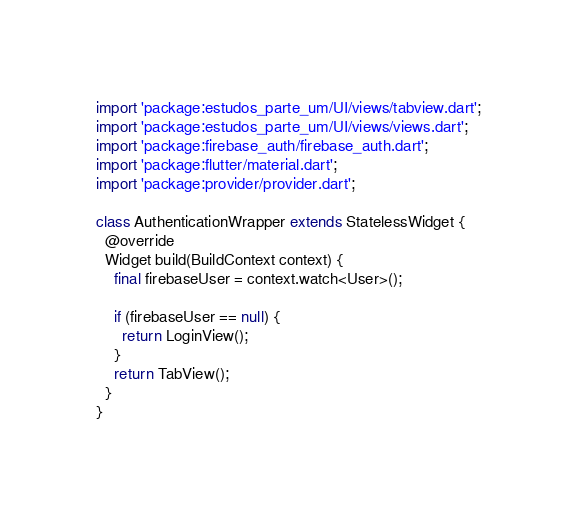<code> <loc_0><loc_0><loc_500><loc_500><_Dart_>import 'package:estudos_parte_um/UI/views/tabview.dart';
import 'package:estudos_parte_um/UI/views/views.dart';
import 'package:firebase_auth/firebase_auth.dart';
import 'package:flutter/material.dart';
import 'package:provider/provider.dart';

class AuthenticationWrapper extends StatelessWidget {
  @override
  Widget build(BuildContext context) {
    final firebaseUser = context.watch<User>();

    if (firebaseUser == null) {
      return LoginView();
    }
    return TabView();
  }
}
</code> 